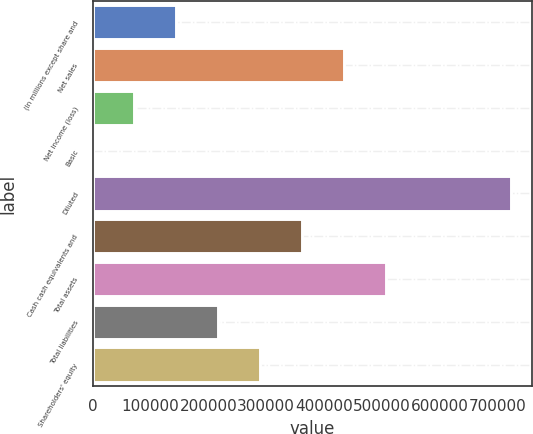Convert chart to OTSL. <chart><loc_0><loc_0><loc_500><loc_500><bar_chart><fcel>(In millions except share and<fcel>Net sales<fcel>Net income (loss)<fcel>Basic<fcel>Diluted<fcel>Cash cash equivalents and<fcel>Total assets<fcel>Total liabilities<fcel>Shareholders' equity<nl><fcel>144714<fcel>434142<fcel>72357.1<fcel>0.09<fcel>723570<fcel>361785<fcel>506499<fcel>217071<fcel>289428<nl></chart> 